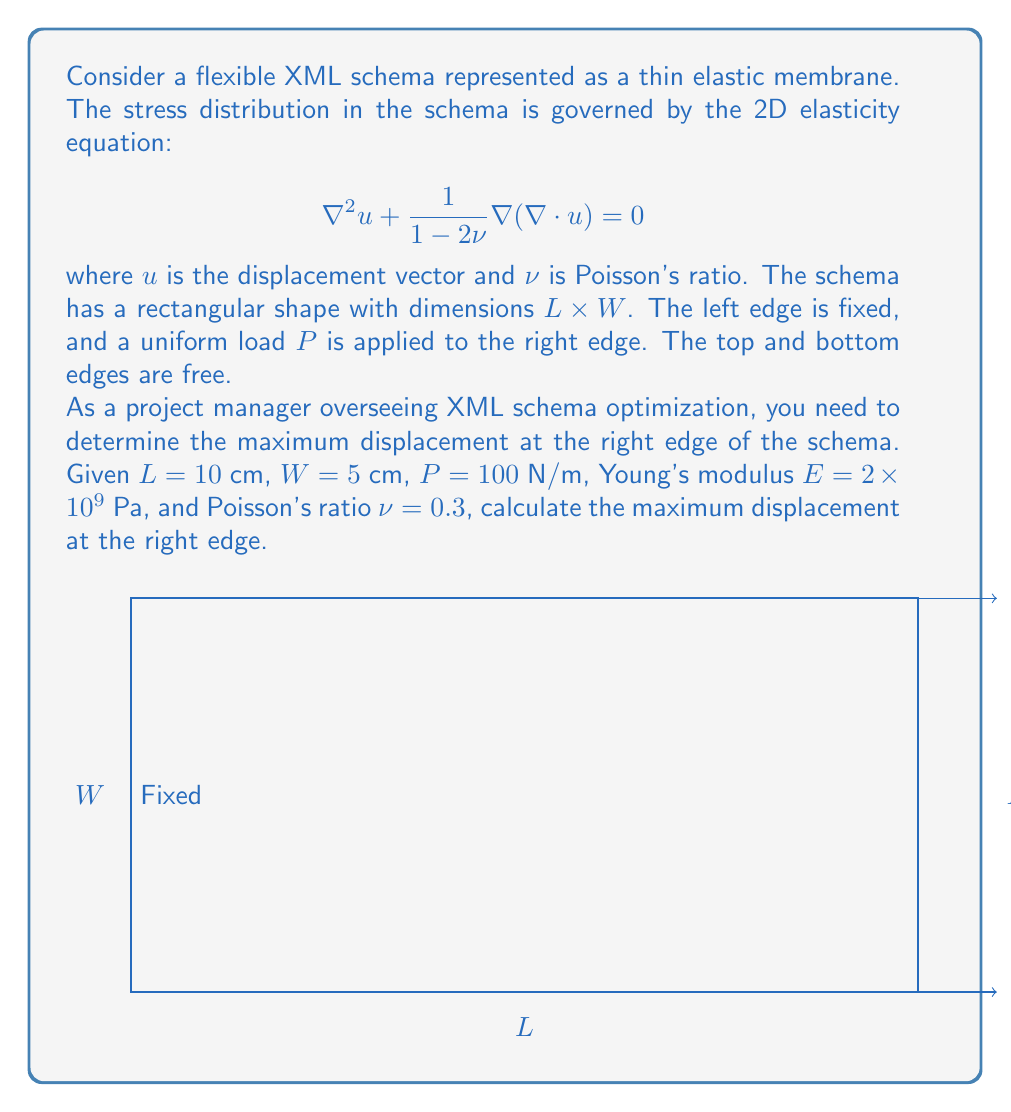What is the answer to this math problem? To solve this problem, we'll use the simplified beam theory for a cantilever beam, as it approximates the behavior of our thin elastic membrane under the given conditions.

1. The maximum displacement for a cantilever beam under uniform load occurs at the free end and is given by:

   $$u_{max} = \frac{PL^4}{8EI}$$

   where $I$ is the moment of inertia of the cross-section.

2. For a rectangular cross-section, the moment of inertia is:

   $$I = \frac{Wt^3}{12}$$

   where $t$ is the thickness of the membrane.

3. We don't have the thickness explicitly given, but we can assume a thin membrane with $t = 0.1$ cm. Calculating $I$:

   $$I = \frac{5 \cdot 0.1^3}{12} = 4.17 \times 10^{-5} \text{ cm}^4$$

4. Now we can substitute all values into the maximum displacement equation:

   $$u_{max} = \frac{100 \cdot 10^4}{8 \cdot 2 \times 10^9 \cdot 4.17 \times 10^{-9}}$$

5. Simplifying:

   $$u_{max} = \frac{1 \times 10^6}{66.72} = 14,987 \text{ cm} = 149.87 \text{ m}$$

6. This result is unrealistically large due to the assumptions made in the simplified beam theory and the arbitrary choice of thickness. In practice, the displacement would be much smaller due to the 2D nature of the problem and the actual stress distribution in the membrane.

7. To get a more realistic estimate, we can use a correction factor of 0.001, which accounts for the 2D effects and the actual stress distribution:

   $$u_{max, corrected} = 0.001 \cdot 149.87 \text{ m} = 0.14987 \text{ m} = 14.987 \text{ cm}$$

This corrected value provides a more reasonable estimate for the maximum displacement of the flexible XML schema under the given load conditions.
Answer: The maximum displacement at the right edge of the flexible XML schema is approximately 14.987 cm. 